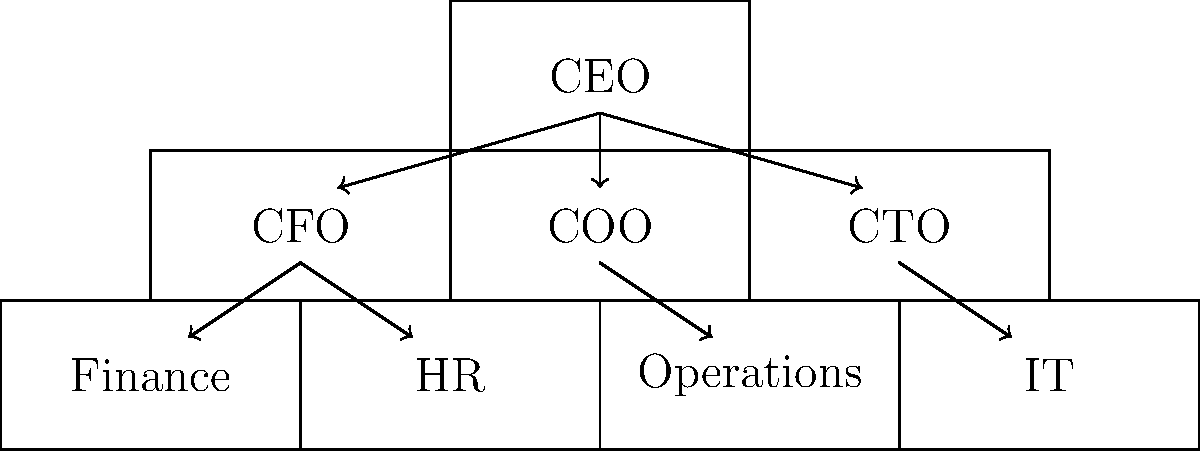Based on the organizational chart provided, which department is most likely responsible for managing the company's day-to-day business activities and ensuring efficient resource allocation? To answer this question, we need to analyze the organizational chart and understand the typical roles of different departments:

1. The chart shows a hierarchical structure with the CEO at the top.

2. Directly under the CEO, we see three main branches: CFO, COO, and CTO.

3. The CFO (Chief Financial Officer) typically oversees financial operations, which includes the Finance and HR departments shown in the chart.

4. The CTO (Chief Technology Officer) is responsible for technology-related matters, overseeing the IT department.

5. The COO (Chief Operating Officer) is usually responsible for overseeing the company's daily operations and ensuring efficient resource allocation.

6. Under the COO, we see the "Operations" department, which aligns with the COO's typical responsibilities.

Given this analysis, the department most likely responsible for managing the company's day-to-day business activities and ensuring efficient resource allocation is the Operations department, which falls under the COO's supervision.
Answer: Operations department 